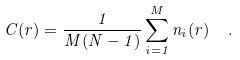<formula> <loc_0><loc_0><loc_500><loc_500>C ( r ) = \frac { 1 } { M ( N - 1 ) } \sum _ { i = 1 } ^ { M } n _ { i } ( r ) \ \ .</formula> 